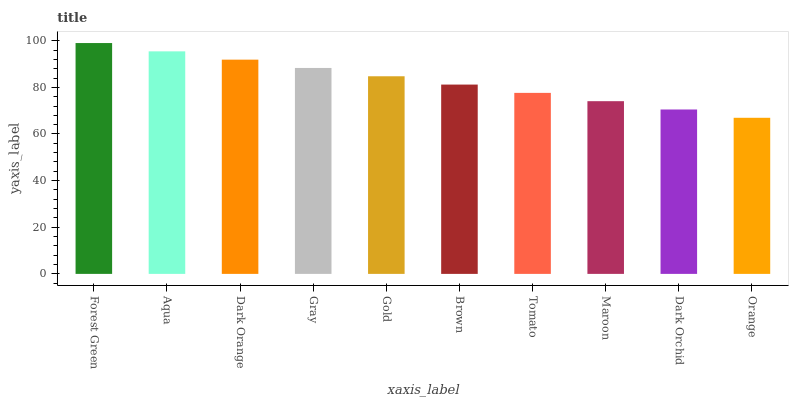Is Orange the minimum?
Answer yes or no. Yes. Is Forest Green the maximum?
Answer yes or no. Yes. Is Aqua the minimum?
Answer yes or no. No. Is Aqua the maximum?
Answer yes or no. No. Is Forest Green greater than Aqua?
Answer yes or no. Yes. Is Aqua less than Forest Green?
Answer yes or no. Yes. Is Aqua greater than Forest Green?
Answer yes or no. No. Is Forest Green less than Aqua?
Answer yes or no. No. Is Gold the high median?
Answer yes or no. Yes. Is Brown the low median?
Answer yes or no. Yes. Is Orange the high median?
Answer yes or no. No. Is Tomato the low median?
Answer yes or no. No. 